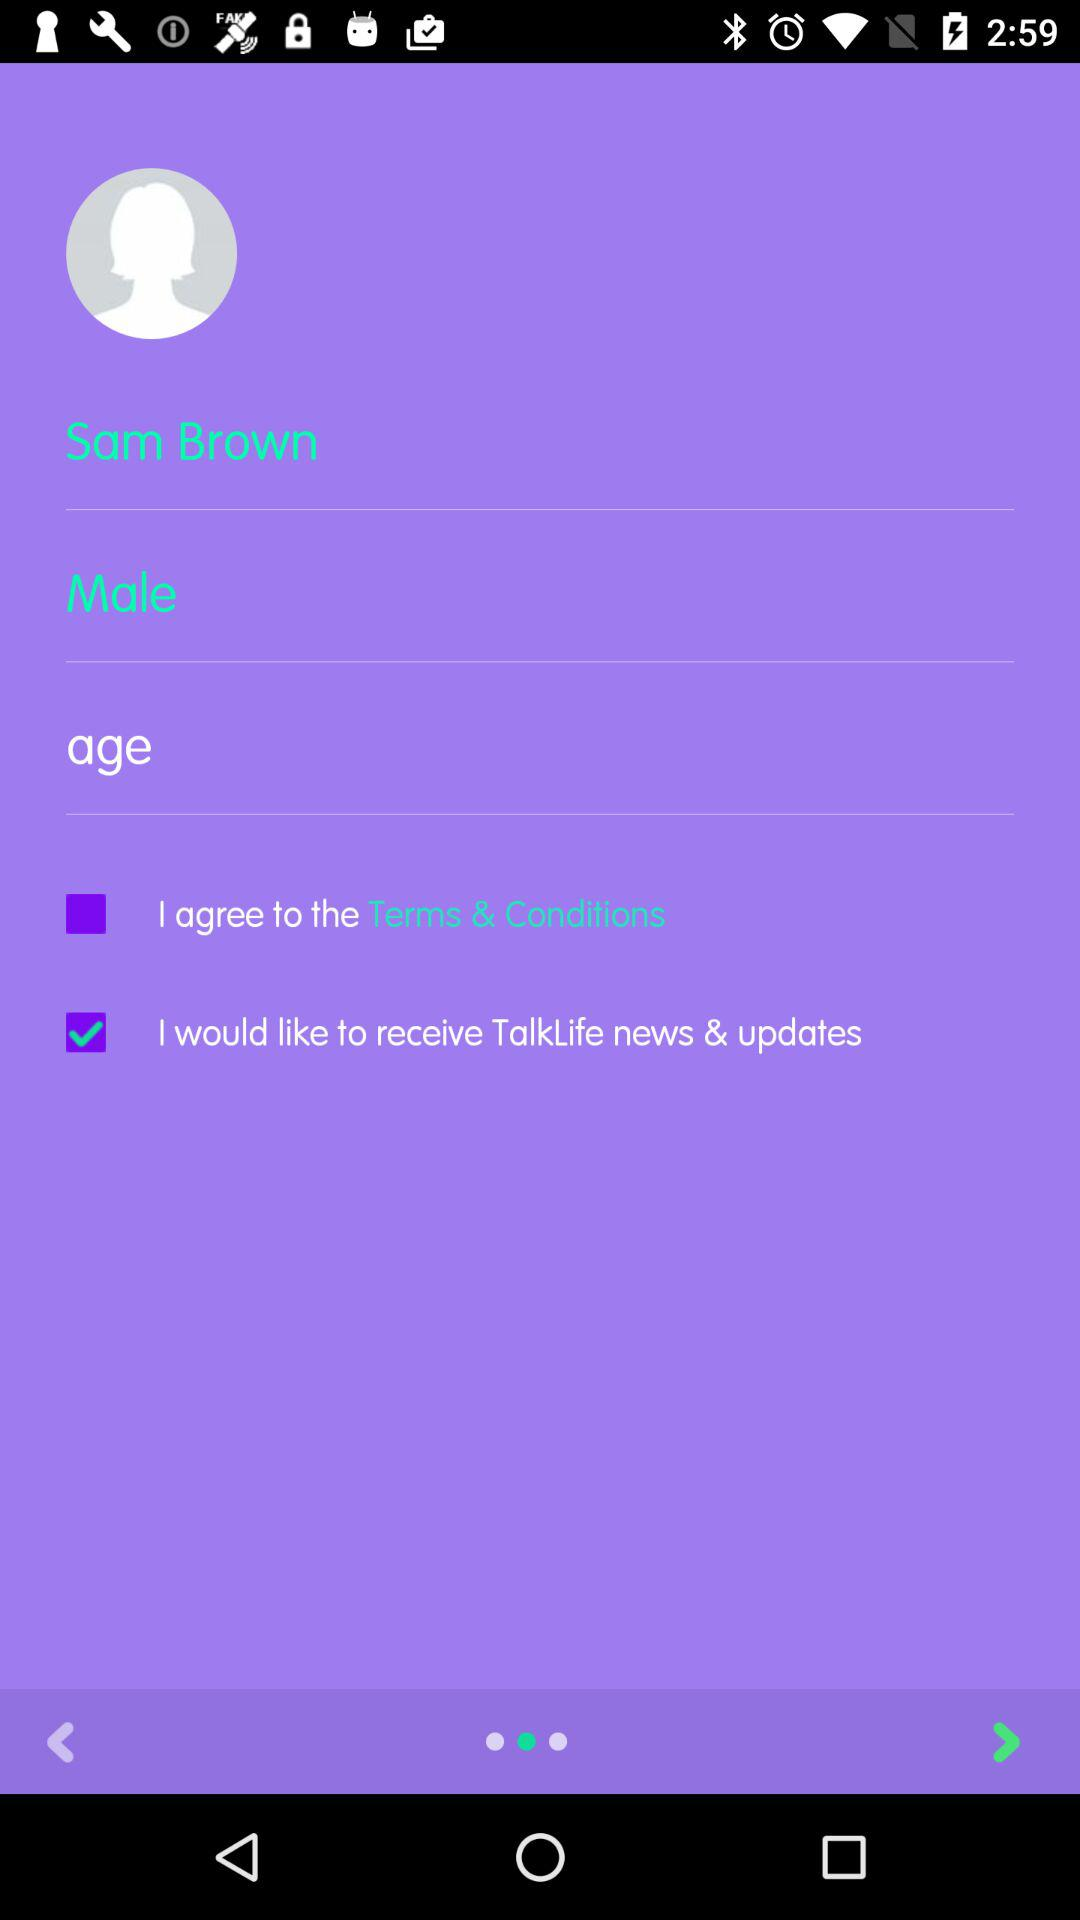What is the user name? The user name is Sam Brown. 